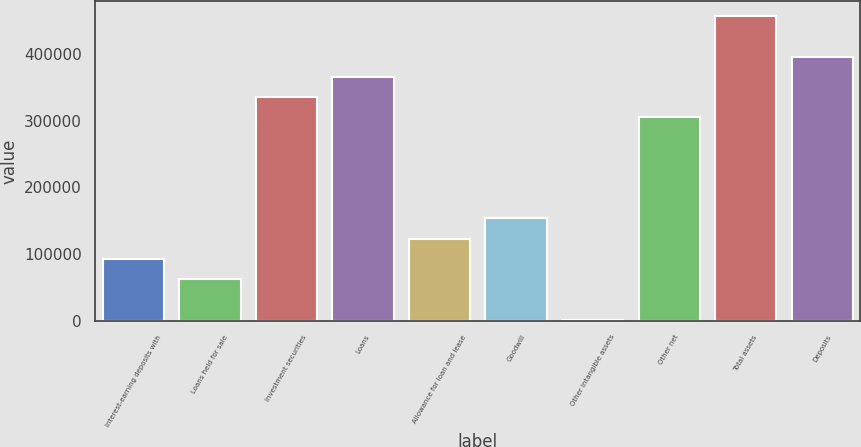<chart> <loc_0><loc_0><loc_500><loc_500><bar_chart><fcel>Interest-earning deposits with<fcel>Loans held for sale<fcel>Investment securities<fcel>Loans<fcel>Allowance for loan and lease<fcel>Goodwill<fcel>Other intangible assets<fcel>Other net<fcel>Total assets<fcel>Deposits<nl><fcel>92790<fcel>62459<fcel>335438<fcel>365769<fcel>123121<fcel>153452<fcel>1797<fcel>305107<fcel>456762<fcel>396100<nl></chart> 